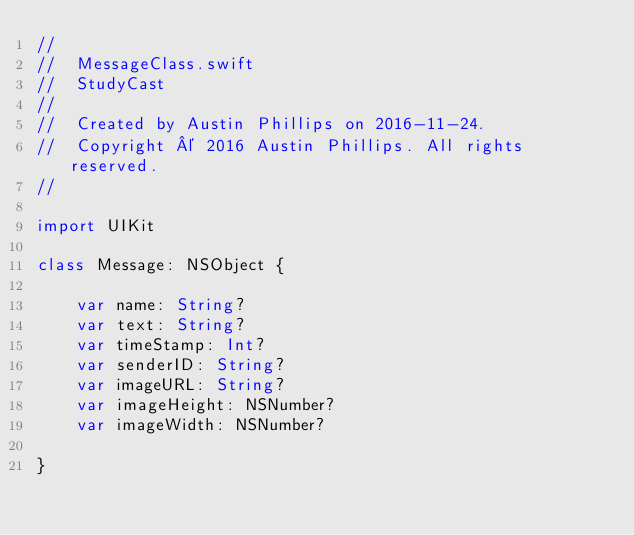Convert code to text. <code><loc_0><loc_0><loc_500><loc_500><_Swift_>//
//  MessageClass.swift
//  StudyCast
//
//  Created by Austin Phillips on 2016-11-24.
//  Copyright © 2016 Austin Phillips. All rights reserved.
//

import UIKit

class Message: NSObject {
    
    var name: String?
    var text: String?
    var timeStamp: Int?
    var senderID: String?
    var imageURL: String?
    var imageHeight: NSNumber?
    var imageWidth: NSNumber?
    
}
</code> 